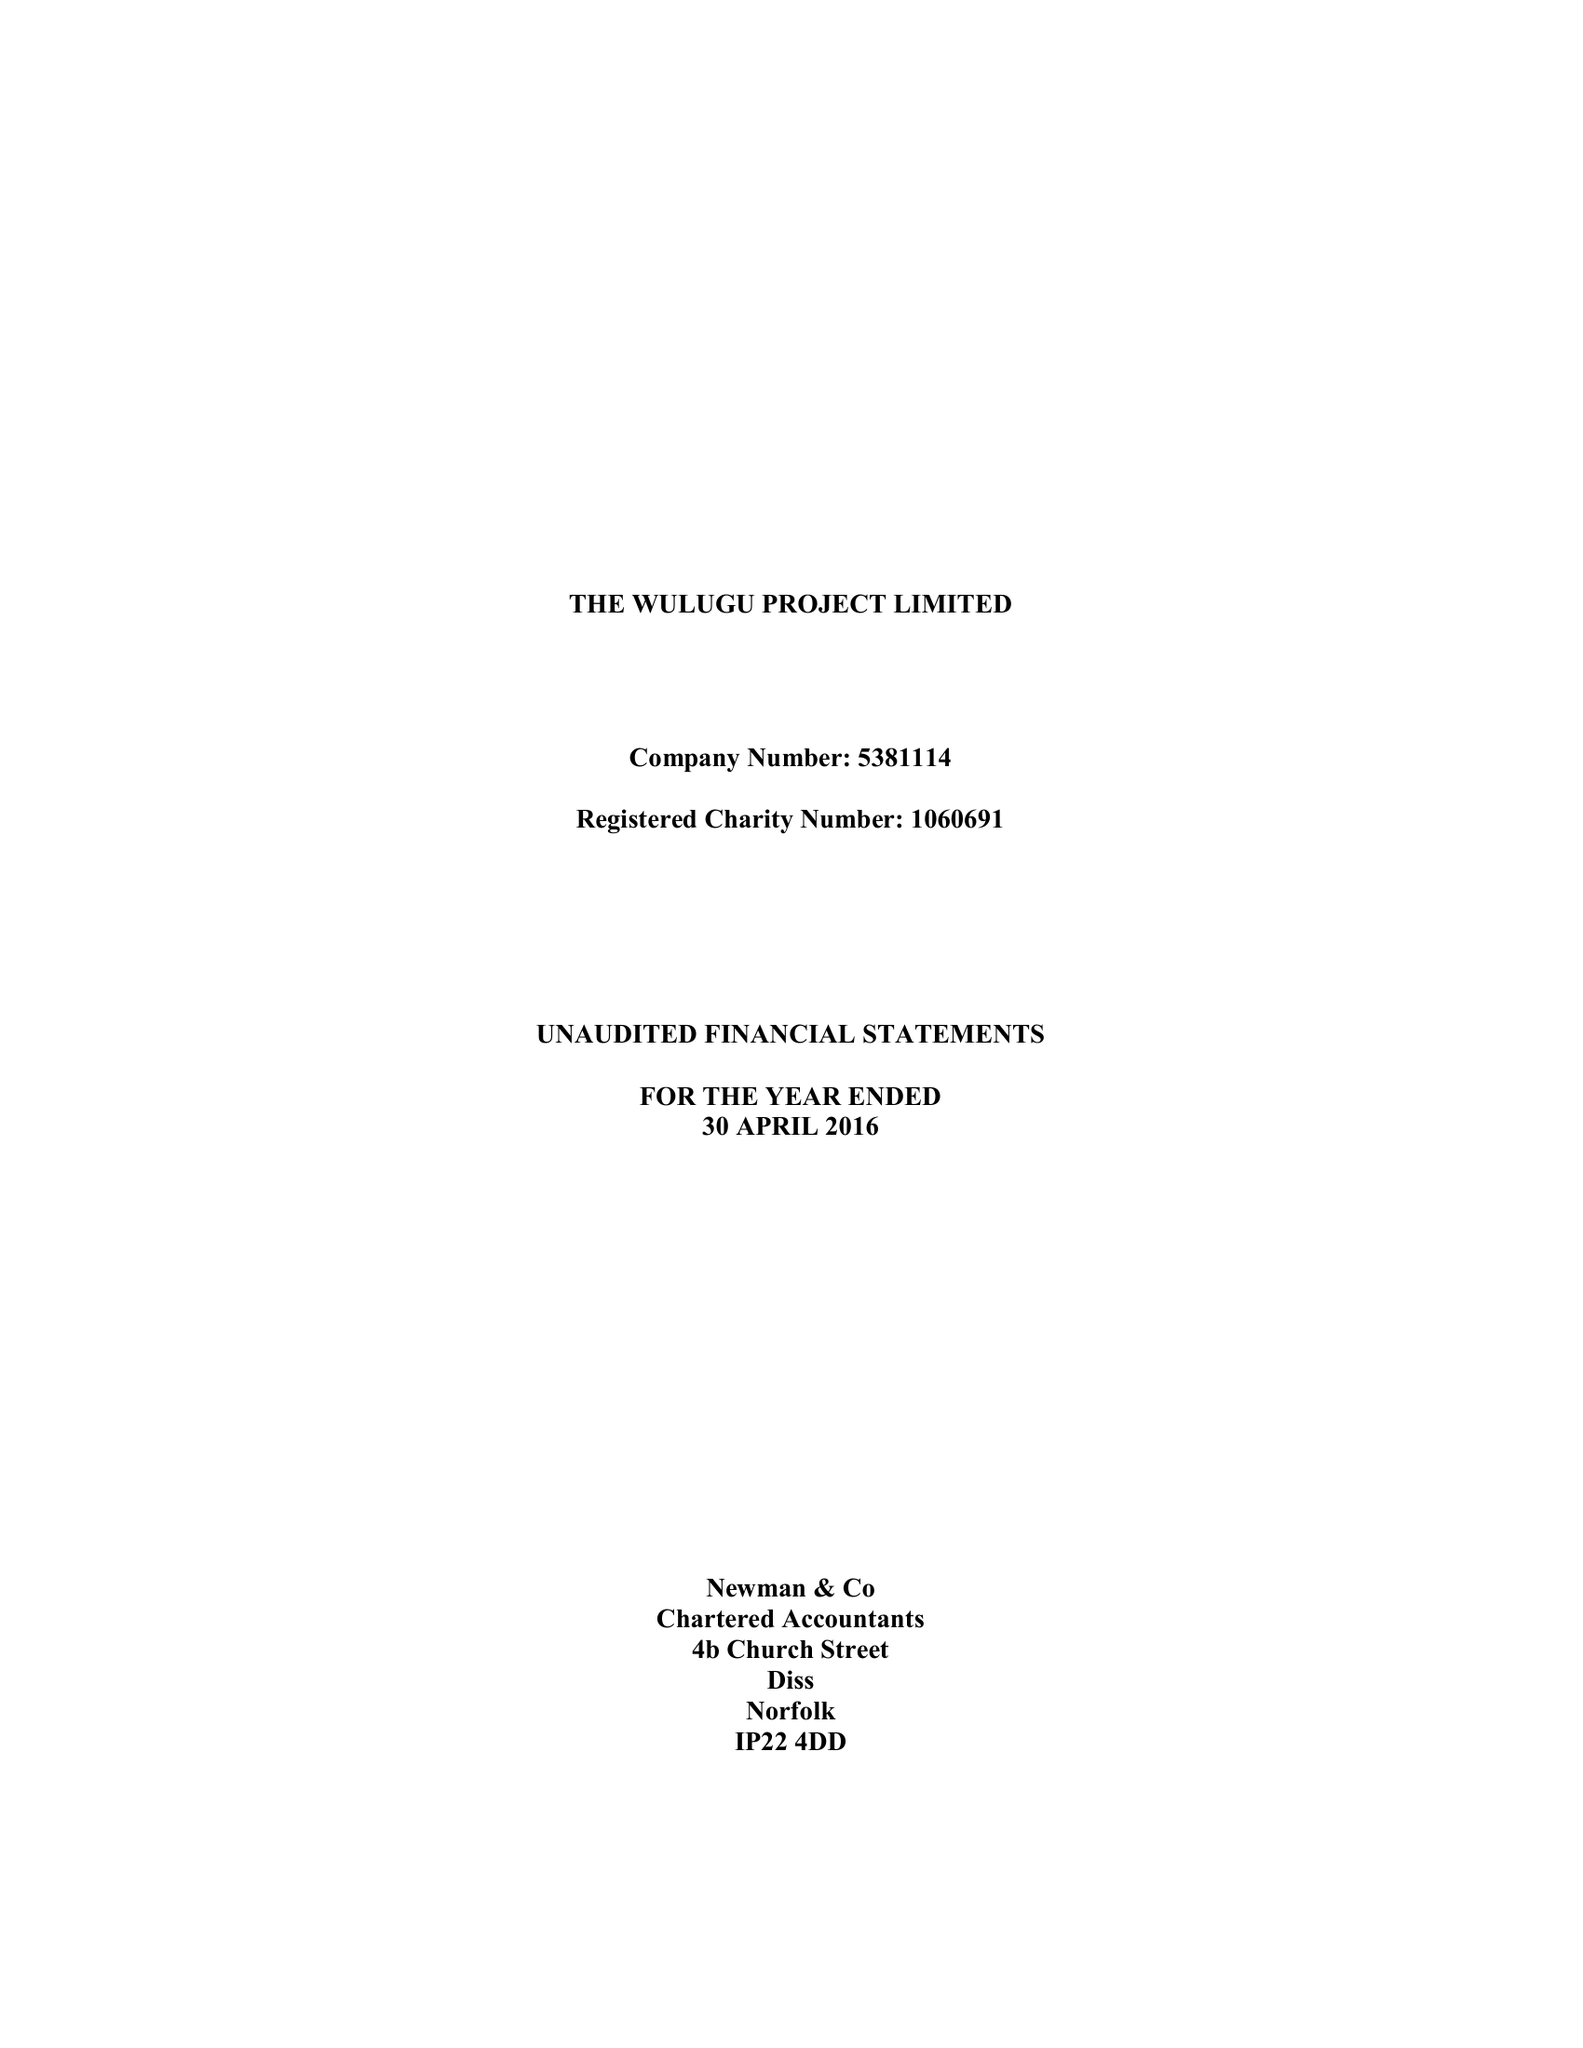What is the value for the address__post_town?
Answer the question using a single word or phrase. NORWICH 